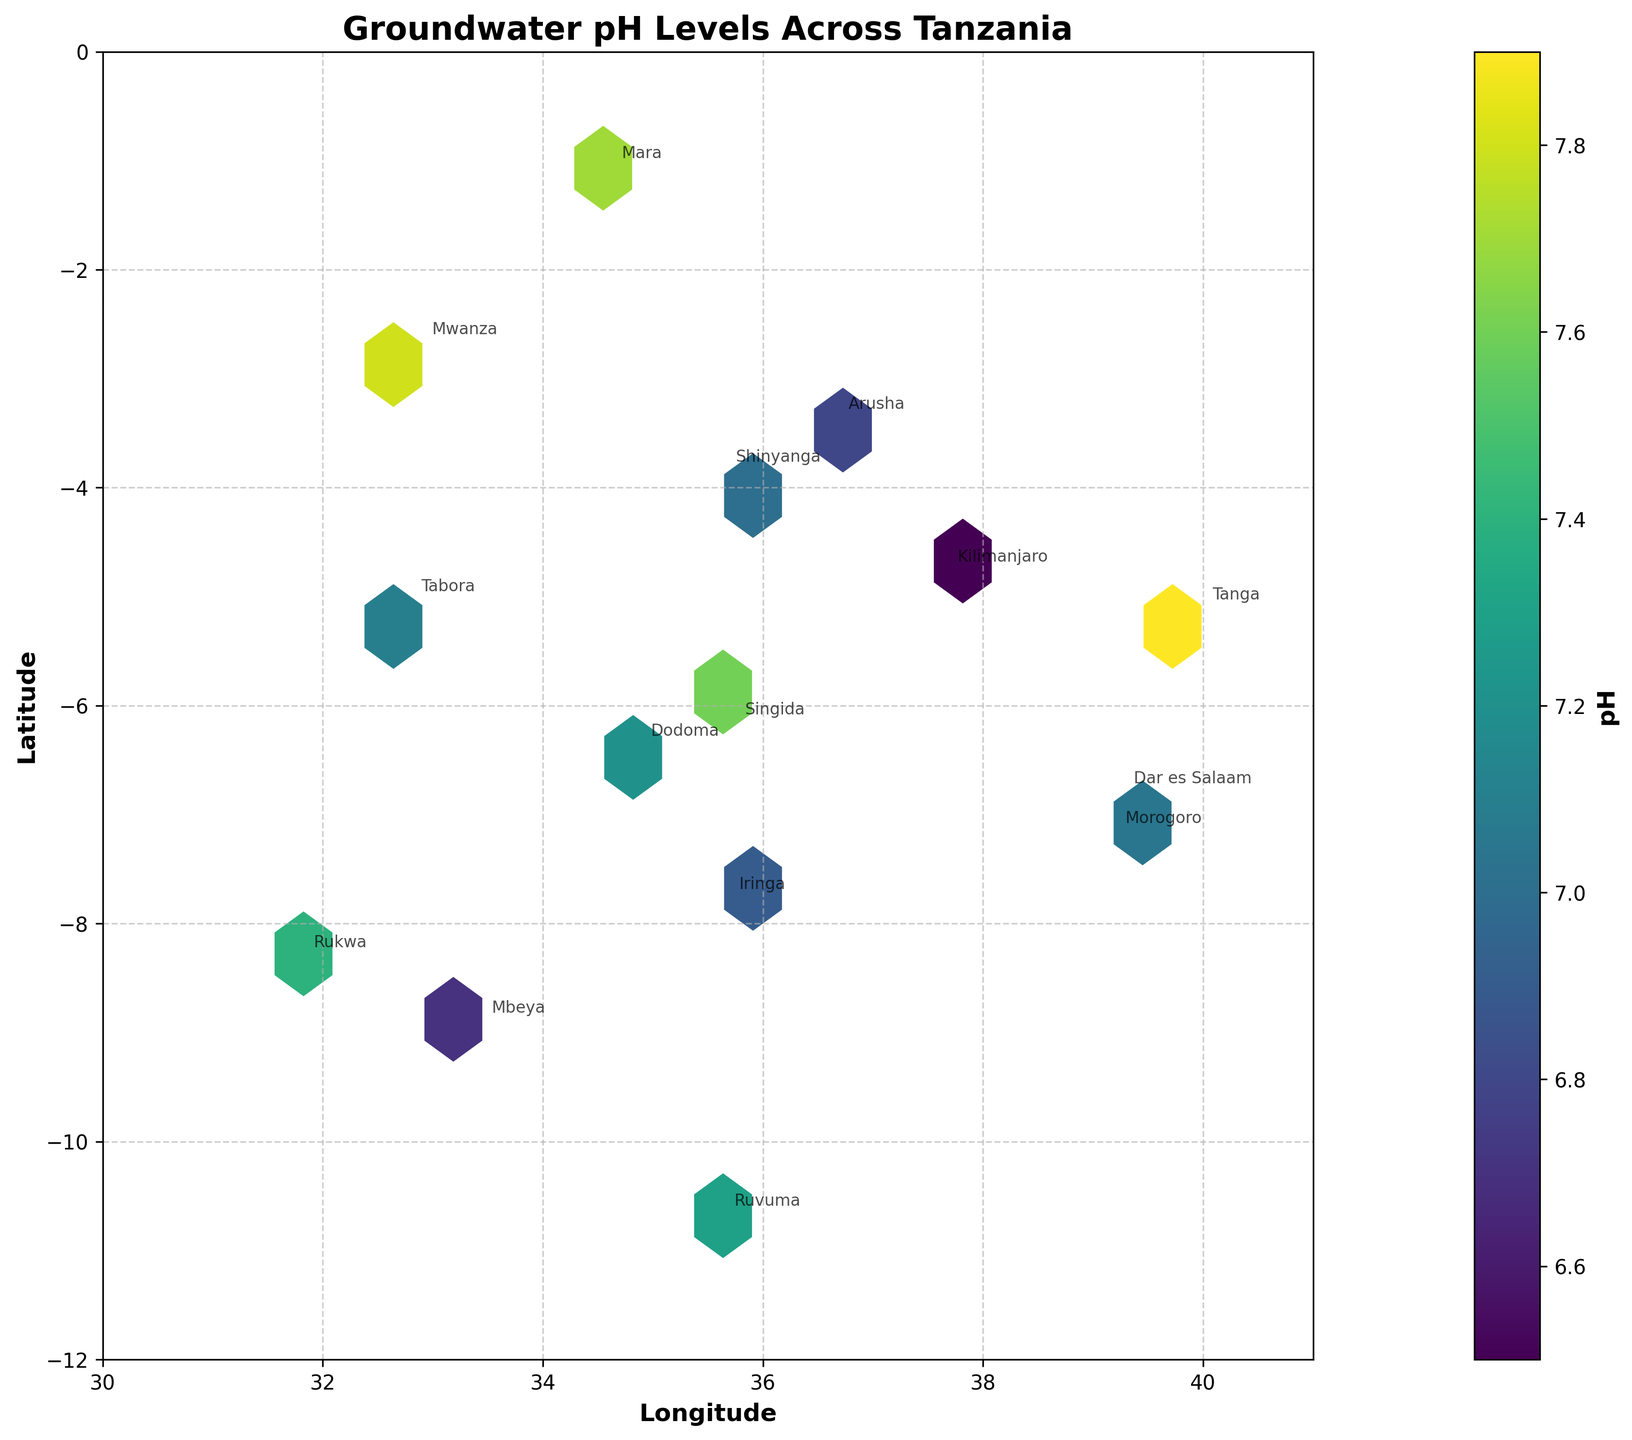What's the title of the figure? The title is located at the top of the figure. It reads 'Groundwater pH Levels Across Tanzania'.
Answer: Groundwater pH Levels Across Tanzania Which region in Tanzania is labeled with the highest pH level? By looking at the colorbar and the hexagons on the plot, Tanga is labeled and has the highest pH level marked in the figure.
Answer: Tanga What's the range of the latitude covered in the figure? The y-axis represents the latitude, and by observing the axis limits, the latitude ranges from approximately -12 to 0.
Answer: -12 to 0 How many regions are annotated on the plot? The annotations for each region can be seen on the plot. Counting them will give the total number of regions labeled.
Answer: 15 Which region shows a pH level closest to 7? By referencing the colorbar and the plotted hexagons, Shinyanga has a pH level that is closest to 7, as the hexagon representing it has a color close to the midpoint of the colorbar.
Answer: Shinyanga Among the regions in the southeastern part of the plot, which one has the highest pH level? Checking the southeastern part of the plot (lower right quadrant), Ruvuma is there and has the highest pH level. The color intensity confirms its higher pH level compared to other nearby regions.
Answer: Ruvuma Are most regions within a pH level of 6.5 to 7.5? Observing the color of most hexagons and matching them with the colorbar, it shows that the majority have colors ranging from the 6.5 to 7.5 range.
Answer: Yes What is the pH level range represented in the colorbar? The colorbar on the right side of the plot provides a continuous range of pH values depicted by colors, spanning from approximately 6.5 to 7.9.
Answer: 6.5 to 7.9 